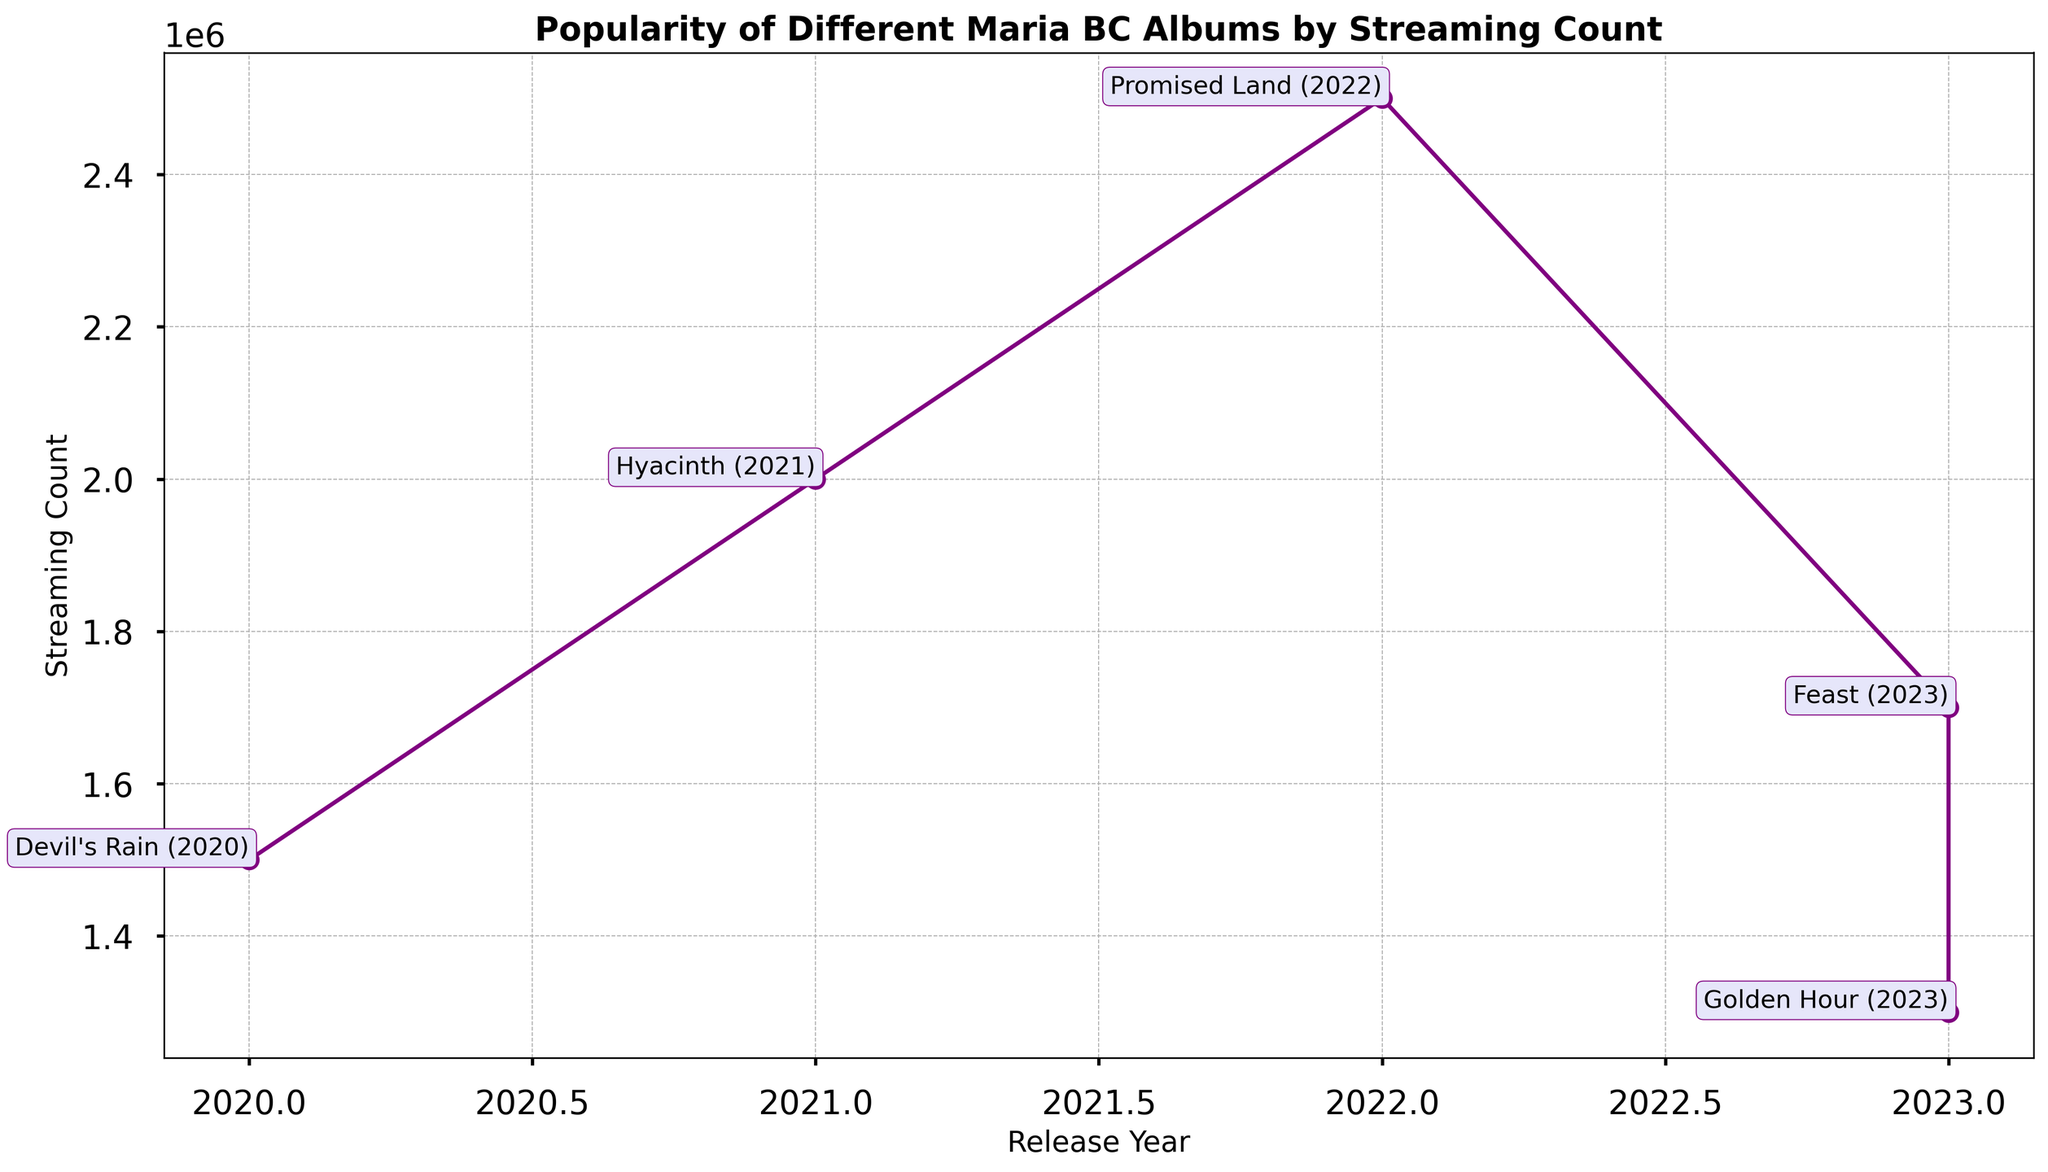Which album was released first and how many streams does it have? By looking at the leftmost annotated point on the figure, we see that "Devil's Rain" was released first and it has 1,500,000 streams.
Answer: Devil's Rain, 1,500,000 streams Which album has the highest streaming count, and in what year was it released? By locating the highest point on the plot, we can see that "Promised Land" has the highest streaming count and it was released in 2022.
Answer: Promised Land, 2022 What is the total streaming count for albums released in 2023? There are two albums released in 2023: "Feast" with 1,700,000 streams and "Golden Hour" with 1,300,000 streams. Summing them up gives 1,700,000 + 1,300,000 = 3,000,000 streams.
Answer: 3,000,000 streams Which albums were released in the same year, and how do their streaming counts compare? The albums "Feast" and "Golden Hour" were both released in 2023. "Feast" has 1,700,000 streams while "Golden Hour" has 1,300,000 streams, so "Feast" has more streams.
Answer: Feast has more streams than Golden Hour What is the average streaming count of all albums released before 2023? The albums released before 2023 are "Devil's Rain" with 1,500,000 streams, "Hyacinth" with 2,000,000 streams, and "Promised Land" with 2,500,000 streams. The average is (1,500,000 + 2,000,000 + 2,500,000) / 3 = 6,000,000 / 3 = 2,000,000 streams.
Answer: 2,000,000 streams Which album shows the biggest increase in streaming count compared to the one released before it? Comparing the increases: "Devil's Rain" to "Hyacinth" (2,000,000 - 1,500,000 = 500,000), "Hyacinth" to "Promised Land" (2,500,000 - 2,000,000 = 500,000), "Promised Land" to "Feast" (1,700,000 - 2,500,000 = -800,000), "Feast" to "Golden Hour" (1,300,000 - 1,700,000 = -400,000). The biggest increase is "Devil's Rain" to "Hyacinth" with 500,000 streams.
Answer: Hyacinth For albums released in consecutive years, which pair has the smallest difference in streaming counts? The pairs are: "Devil's Rain" (2020) to "Hyacinth" (2021) with 500,000 difference, "Hyacinth" (2021) to "Promised Land" (2022) with 500,000 difference, "Promised Land" (2022) to "Feast" (2023) with -800,000 difference, and "Feast" (2023) to "Golden Hour" (2023) with -400,000 difference. The smallest absolute difference is 400,000 between "Feast" and "Golden Hour".
Answer: Feast and Golden Hour What is the median streaming count for all the albums? The streaming counts are 1,300,000, 1,500,000, 1,700,000, 2,000,000, 2,500,000. The median value, which is the middle number in this sorted list, is 1,700,000 streams.
Answer: 1,700,000 streams 